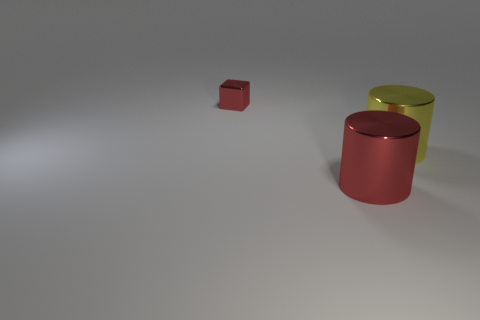There is a thing that is the same color as the cube; what is it made of?
Ensure brevity in your answer.  Metal. There is a tiny red metal cube; how many red cylinders are behind it?
Offer a very short reply. 0. Is the number of red cylinders that are left of the red cylinder less than the number of large yellow metal cylinders that are behind the big yellow metal cylinder?
Offer a terse response. No. What number of tiny gray metal blocks are there?
Provide a short and direct response. 0. There is a shiny cylinder that is to the left of the yellow object; what is its color?
Provide a succinct answer. Red. The yellow thing is what size?
Make the answer very short. Large. There is a small cube; is it the same color as the large thing to the left of the yellow thing?
Your answer should be compact. Yes. The metallic object that is on the left side of the red metal object that is in front of the block is what color?
Provide a succinct answer. Red. Is there any other thing that has the same size as the red shiny cylinder?
Your answer should be compact. Yes. There is a red metal object that is in front of the tiny cube; does it have the same shape as the small red object?
Your response must be concise. No. 